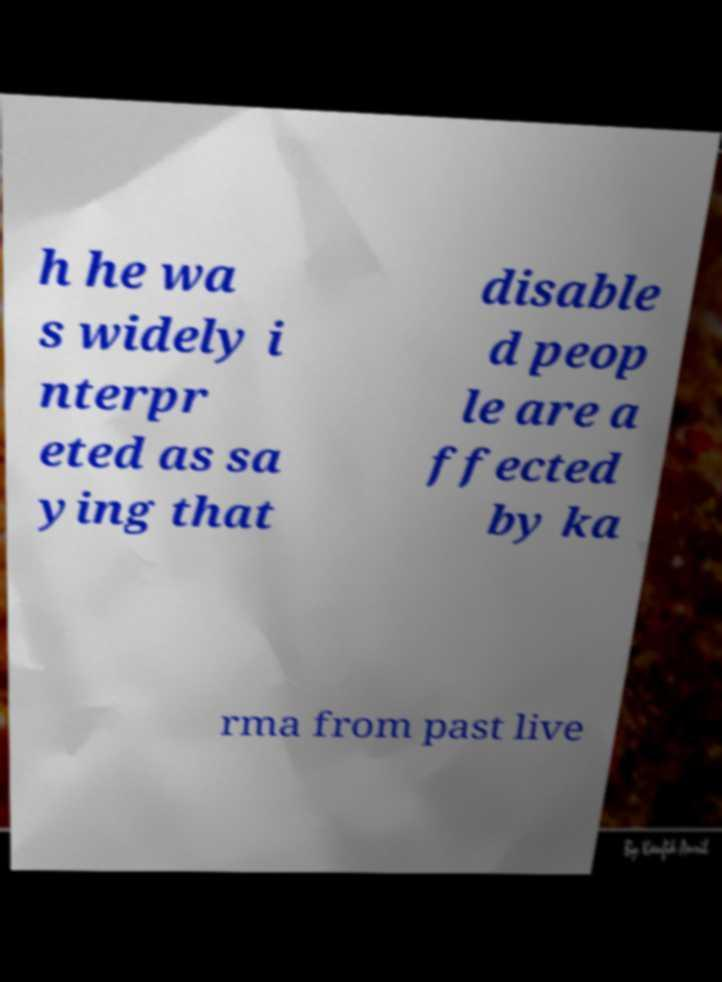I need the written content from this picture converted into text. Can you do that? h he wa s widely i nterpr eted as sa ying that disable d peop le are a ffected by ka rma from past live 